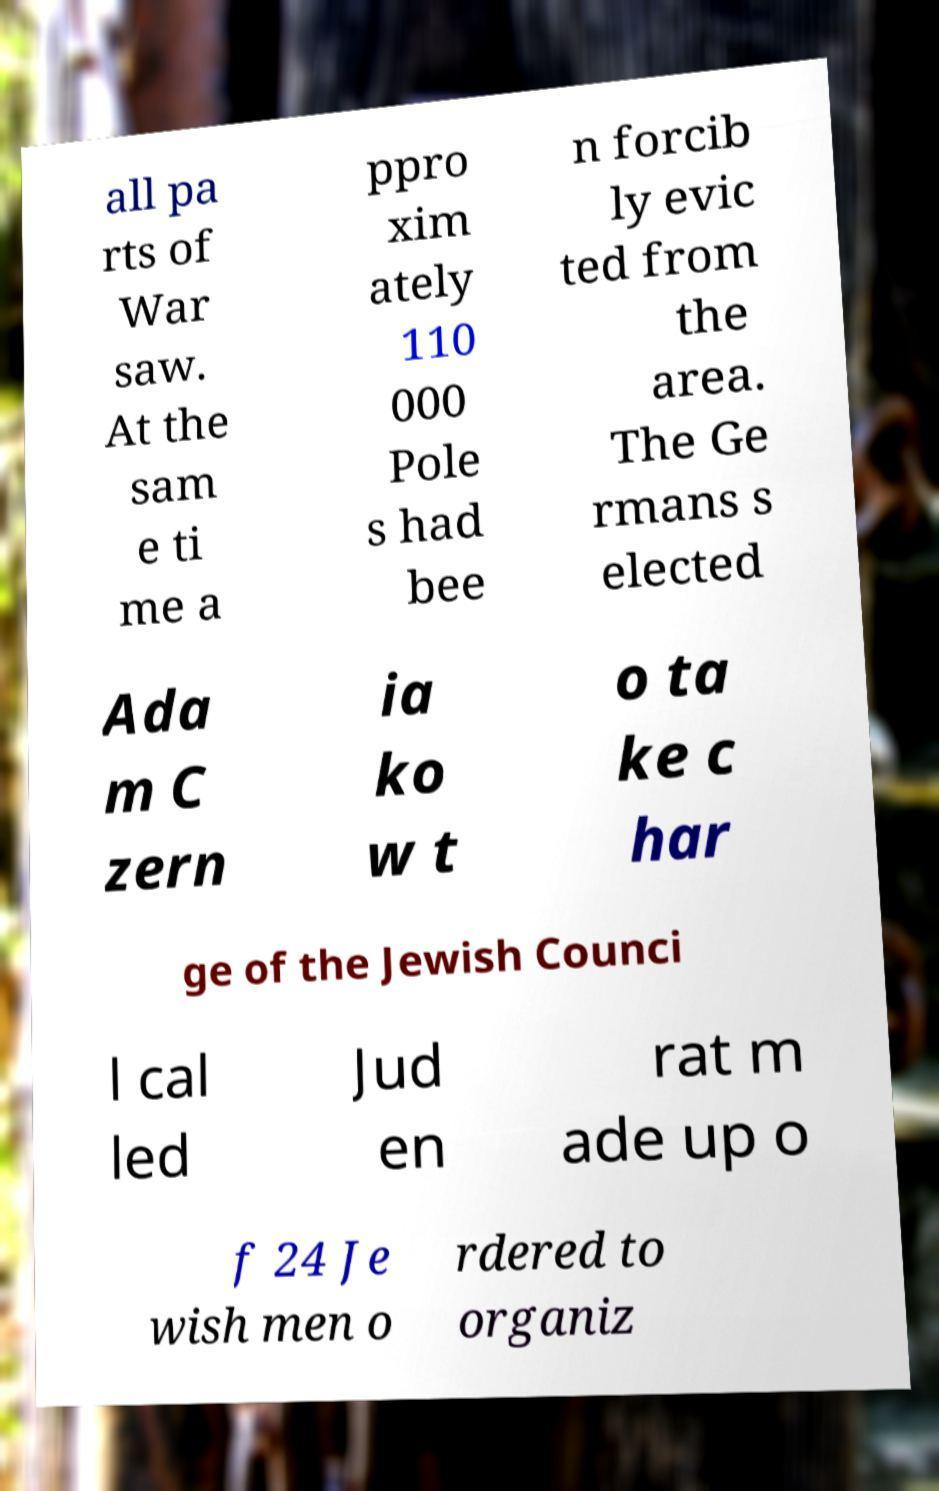What messages or text are displayed in this image? I need them in a readable, typed format. all pa rts of War saw. At the sam e ti me a ppro xim ately 110 000 Pole s had bee n forcib ly evic ted from the area. The Ge rmans s elected Ada m C zern ia ko w t o ta ke c har ge of the Jewish Counci l cal led Jud en rat m ade up o f 24 Je wish men o rdered to organiz 